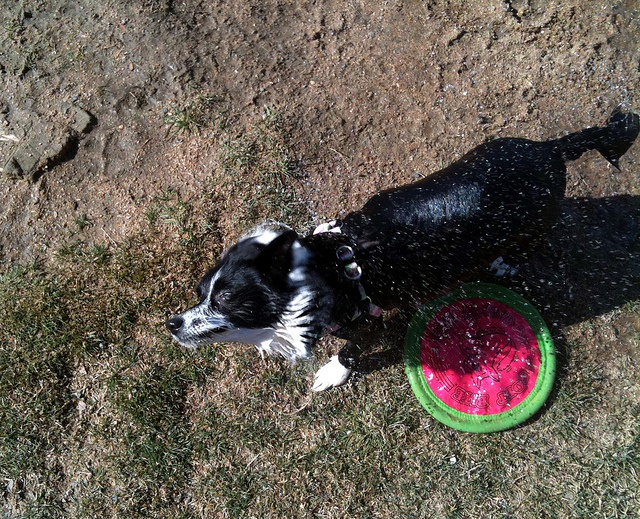Describe the objects in this image and their specific colors. I can see dog in gray, black, and white tones and frisbee in gray, black, maroon, brown, and green tones in this image. 